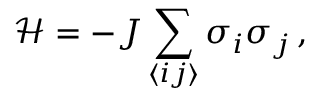Convert formula to latex. <formula><loc_0><loc_0><loc_500><loc_500>\mathcal { H } = - J \sum _ { \langle i j \rangle } \sigma _ { i } \sigma _ { j } \, ,</formula> 